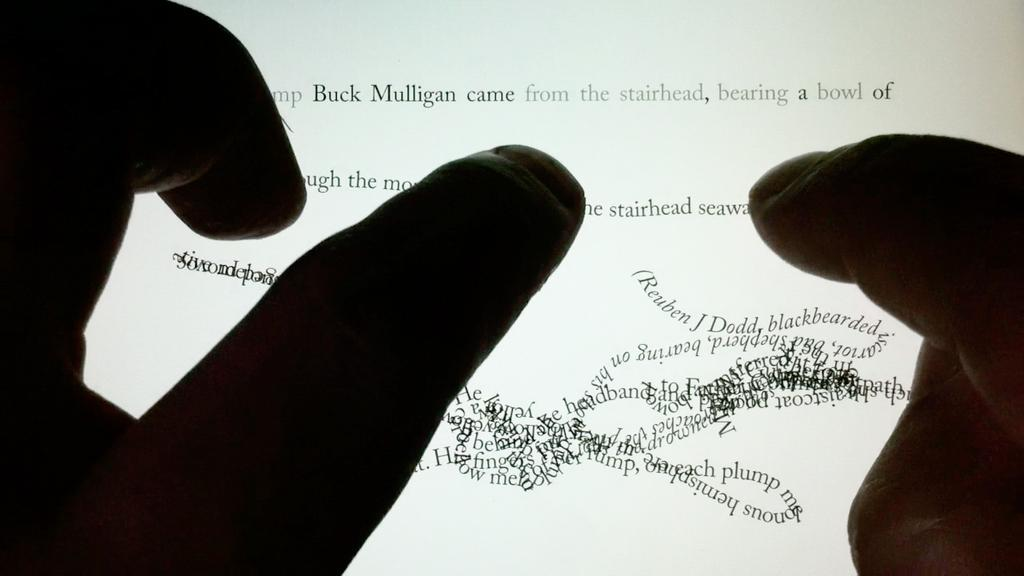What body part is visible in the image? There are fingers visible in the image. To whom do the fingers belong? The fingers belong to a person. What is in front of the fingers in the image? There is a digital screen in front of the fingers. What can be seen on the digital screen? There is text present on the digital screen. Are there any cherries visible on the digital screen? There are no cherries visible on the digital screen; the screen only displays text. 